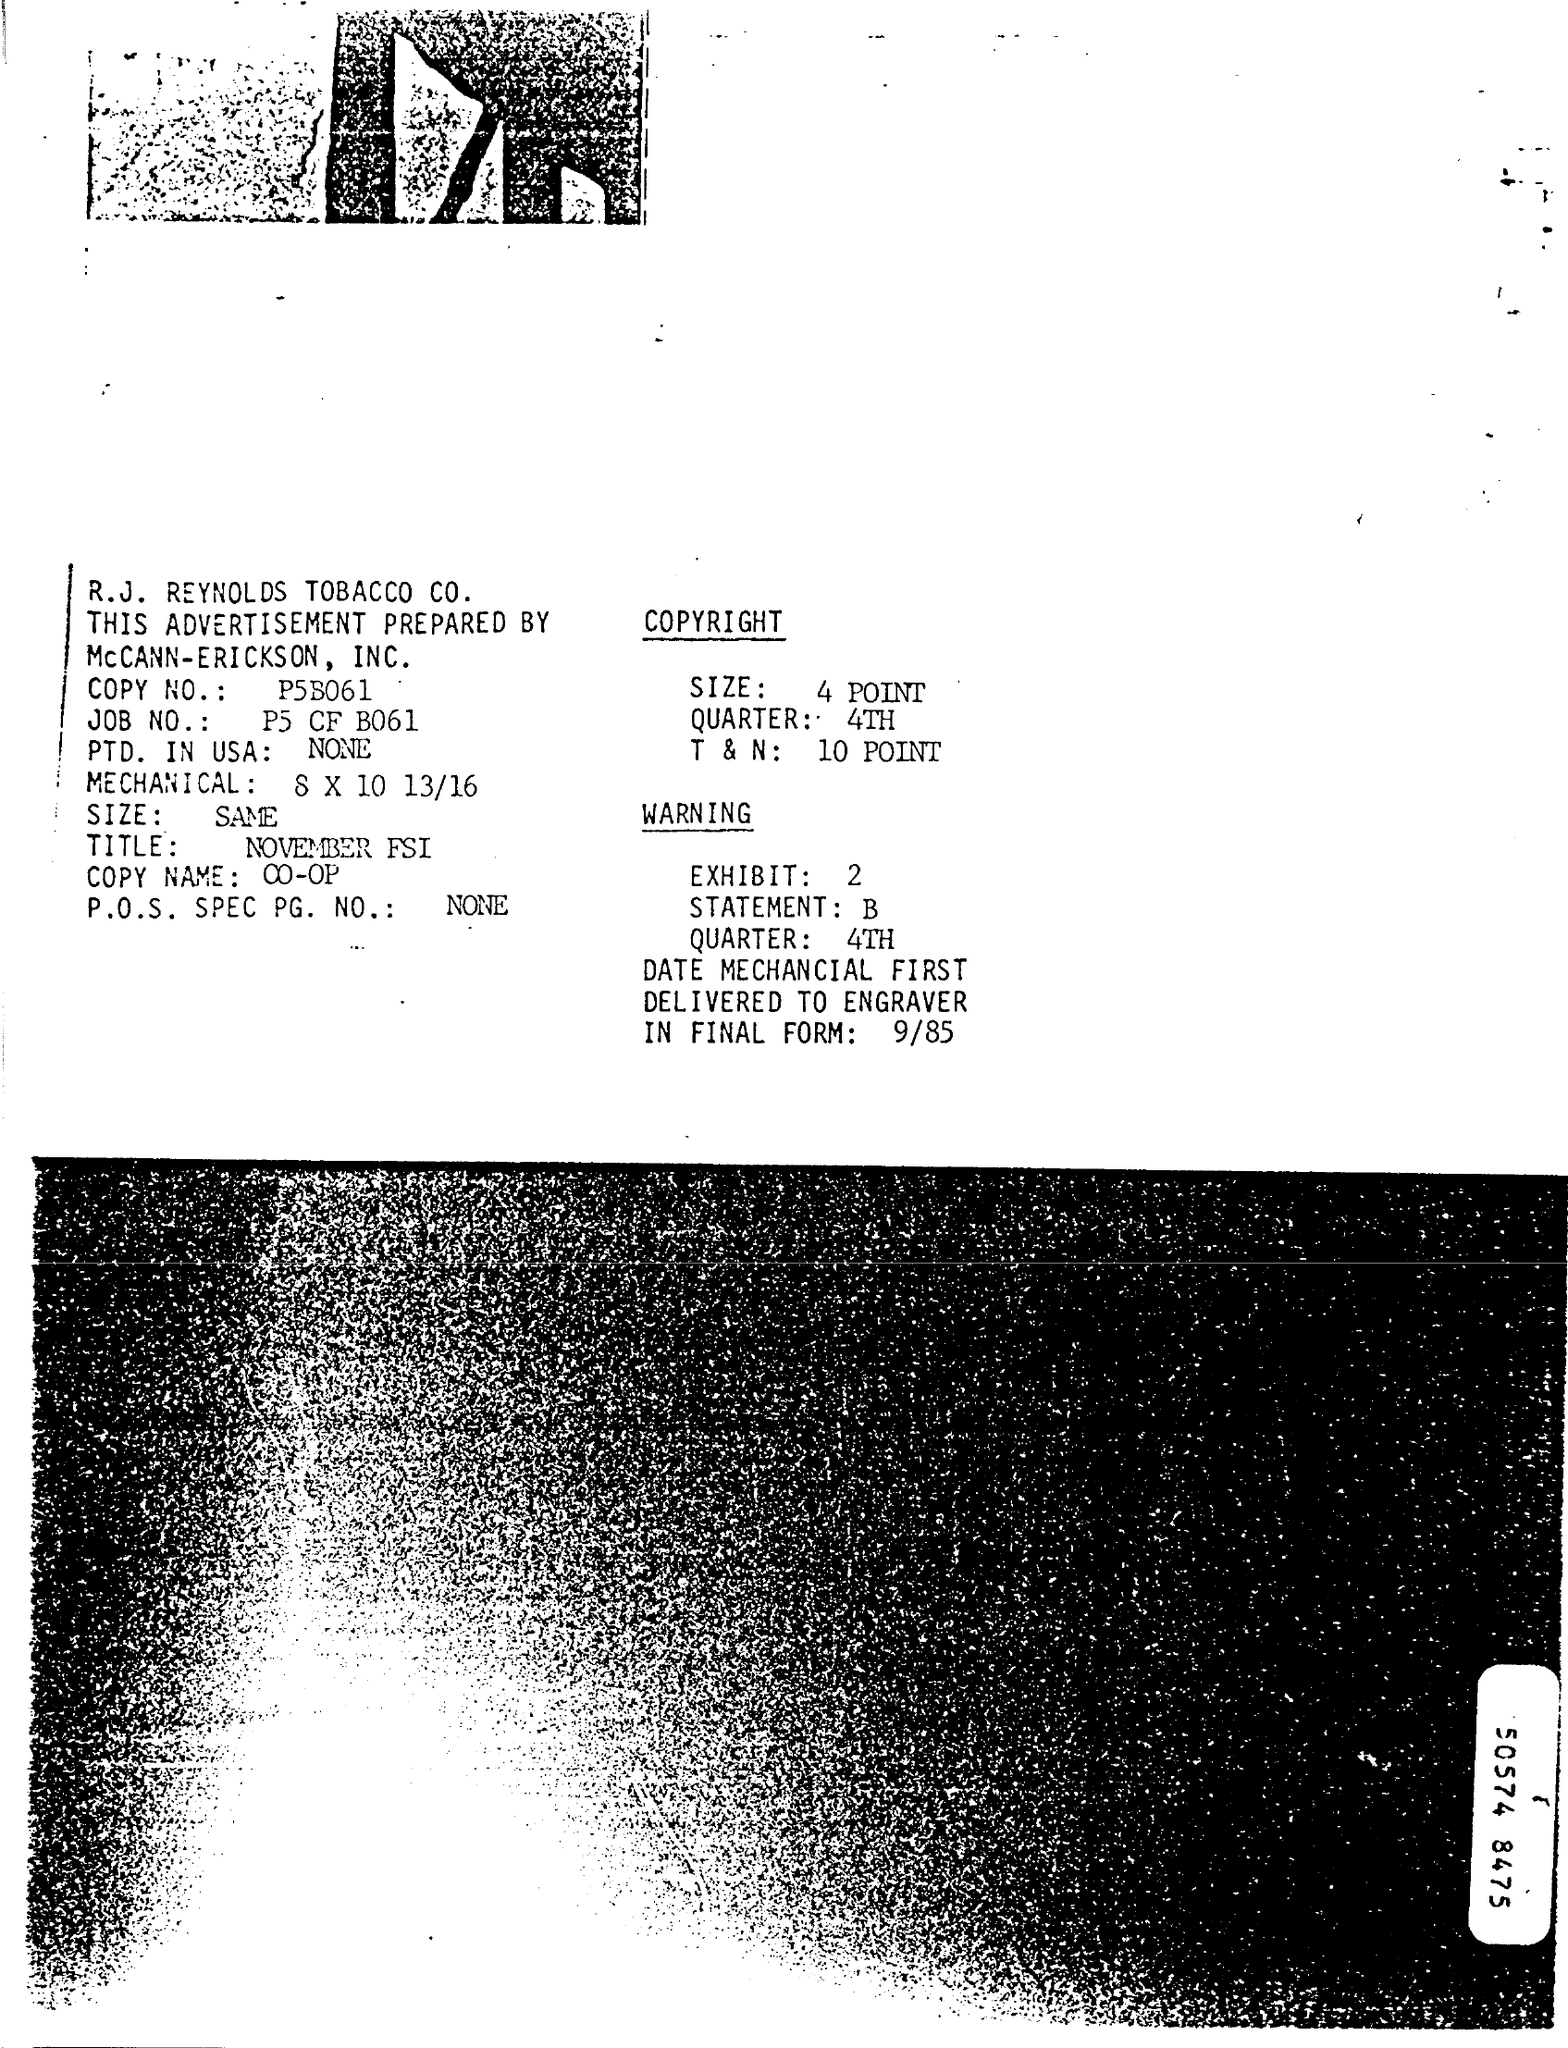Point out several critical features in this image. The name of the company is R.J. Reynolds Tobacco Company. The JOB number is P5 CF B061. The total and net value of the copyright is 10 points. The copy number is p5B061. Which quarter is mentioned in the warning? The 4th quarter. 